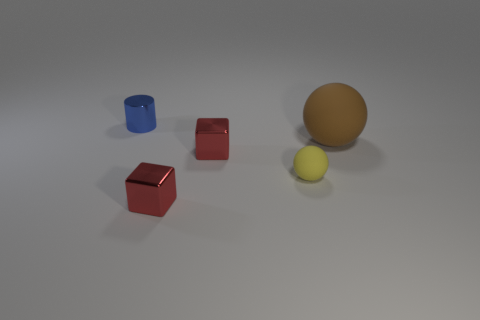Add 1 big red matte cylinders. How many objects exist? 6 Subtract all cylinders. How many objects are left? 4 Add 5 cubes. How many cubes exist? 7 Subtract 1 brown spheres. How many objects are left? 4 Subtract all tiny brown shiny cylinders. Subtract all metal things. How many objects are left? 2 Add 2 tiny yellow spheres. How many tiny yellow spheres are left? 3 